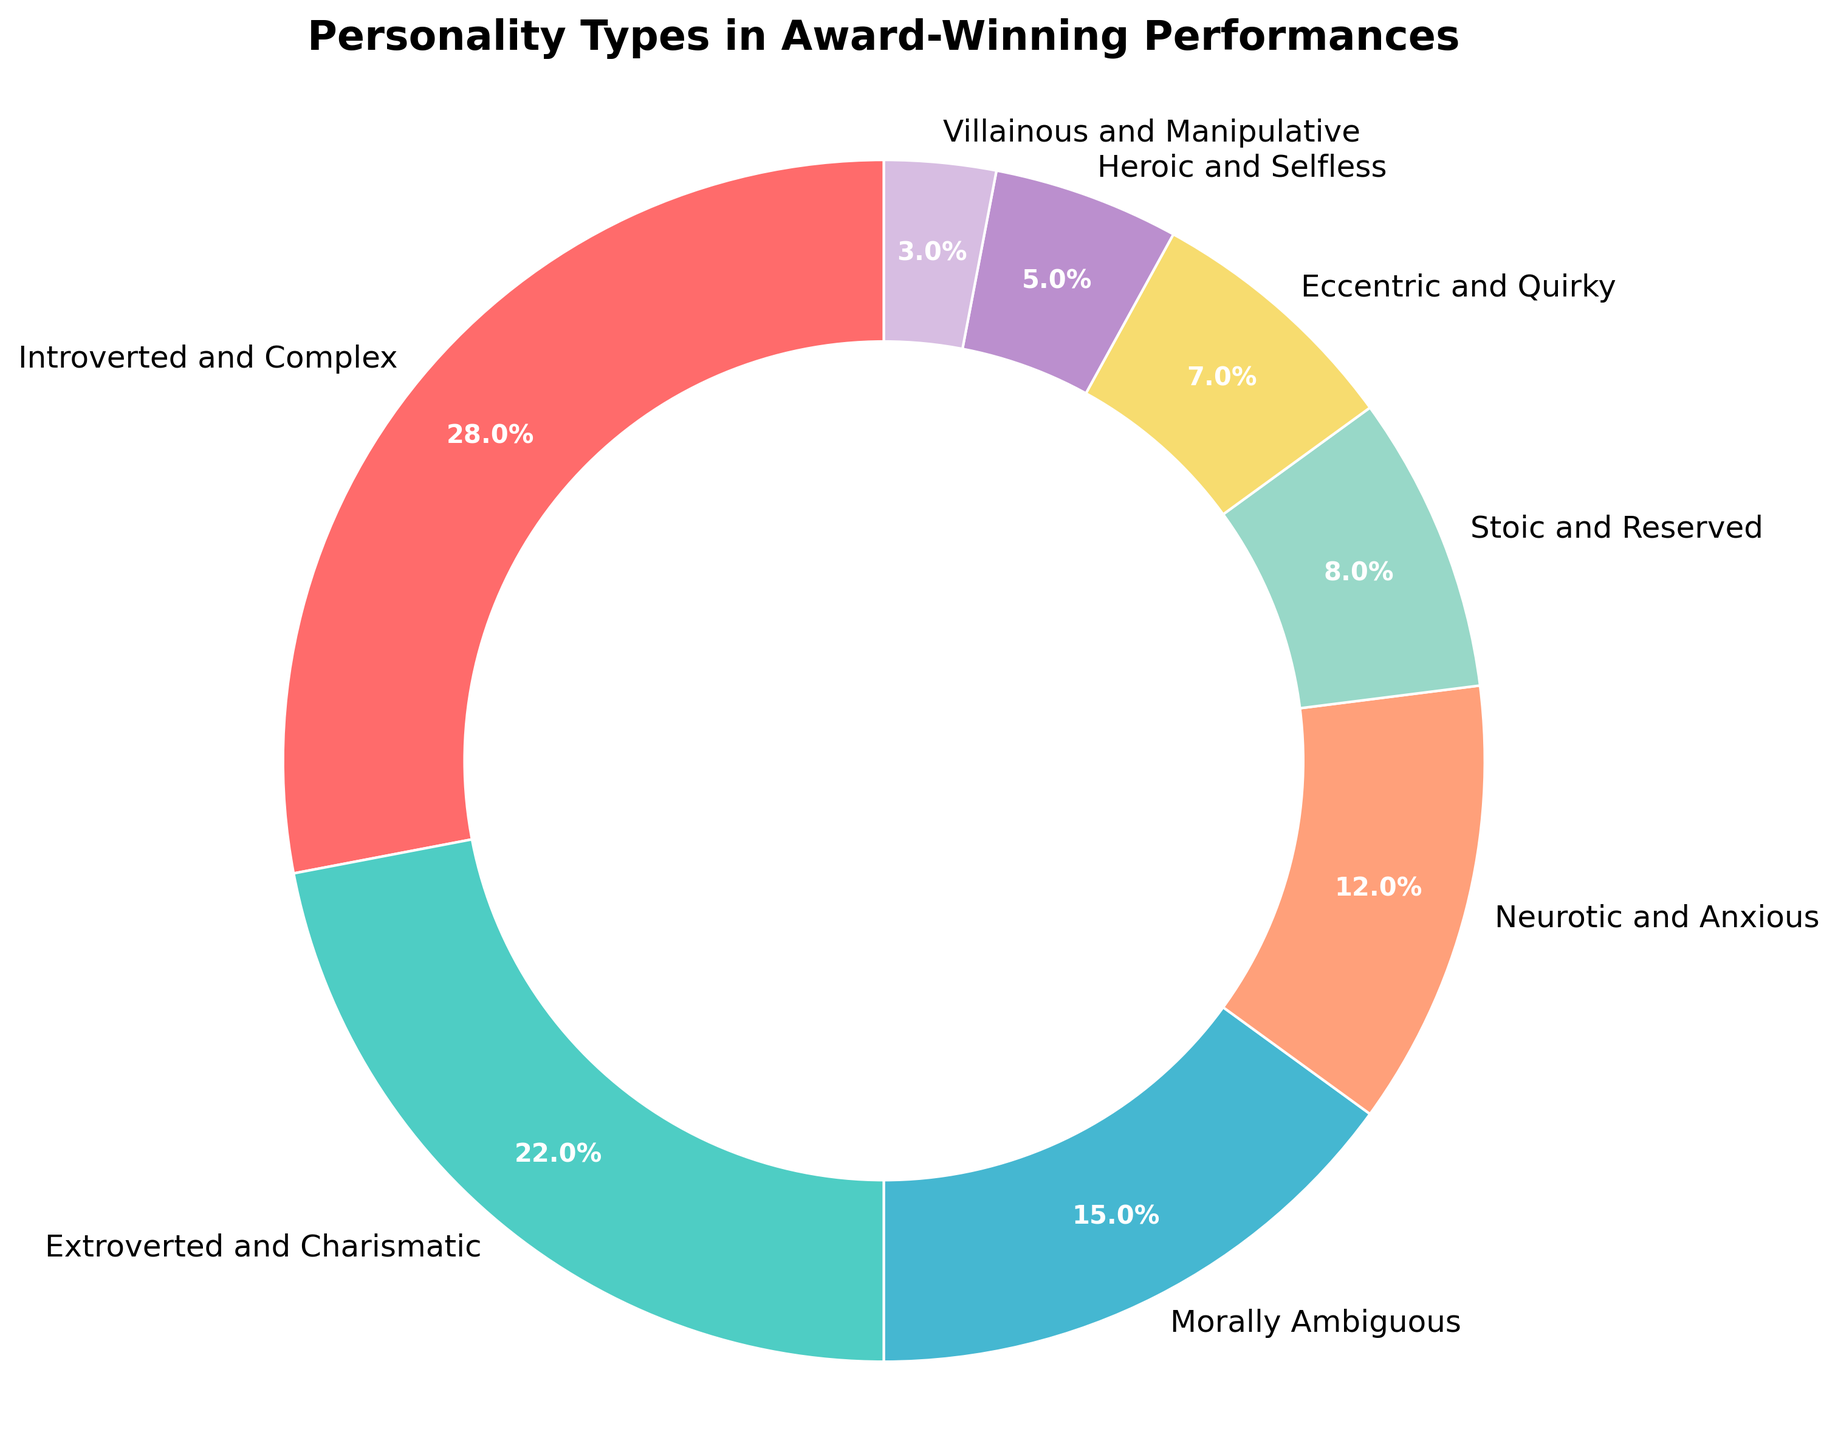What is the most common personality type portrayed in award-winning performances over the past decade? The chart shows various personality types with their corresponding percentages. The segment labeled "Introverted and Complex" has the largest percentage at 28%.
Answer: Introverted and Complex Which two personality types together make up more than 40% of the total? Adding the percentages of "Introverted and Complex" (28%) and "Extroverted and Charismatic" (22%) gives 50%, which is more than 40%.
Answer: Introverted and Complex, Extroverted and Charismatic How does the proportion of Heroic and Selfless characters compare to Villainous and Manipulative characters? The percentage of "Heroic and Selfless" is 5%, while "Villainous and Manipulative" is 3%. Comparing these values, 5% is greater than 3%.
Answer: Heroic and Selfless is greater than Villainous and Manipulative Which personality type is represented by the color red? The color red corresponds to the segment labeled "Introverted and Complex" in the pie chart.
Answer: Introverted and Complex If you sum the percentages of Morally Ambiguous, Neurotic and Anxious, and Stoic and Reserved characters, what is the total? Adding 15% (Morally Ambiguous) + 12% (Neurotic and Anxious) + 8% (Stoic and Reserved) results in a total of 35%.
Answer: 35% Which personality type occupies the smallest portion of the chart? The segment labeled "Villainous and Manipulative" has the smallest percentage at 3%.
Answer: Villainous and Manipulative In terms of percentage, how much more common are Introverted and Complex characters compared to Eccentric and Quirky characters? Subtracting the percentage of "Eccentric and Quirky" (7%) from "Introverted and Complex" (28%) gives 21%.
Answer: 21% What is the average percentage of the top three most common personality types? The top three percentages are 28% (Introverted and Complex), 22% (Extroverted and Charismatic), and 15% (Morally Ambiguous). Their sum is 65%, and the average is 65/3 ≈ 21.67%.
Answer: 21.67% Which color represents the Extroverted and Charismatic personality type? The Extroverted and Charismatic personality type is represented by the color green.
Answer: Green If the total percentage of Introverted and Complex and Extroverted and Charismatic characters is 50%, what percentage do all the other types occupy? If Introverted and Complex and Extroverted and Charismatic make up 50%, then the remaining types together occupy the rest, which is 100% - 50% = 50%.
Answer: 50% 